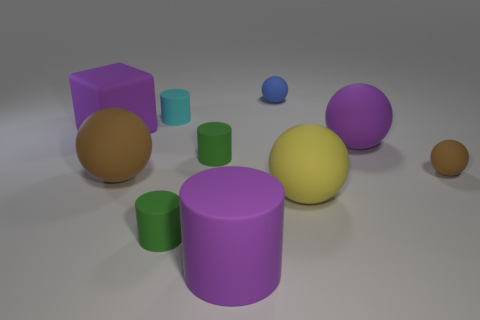Are there any purple things that are to the left of the small ball in front of the small cylinder behind the large matte block?
Your answer should be compact. Yes. There is a big purple object that is the same shape as the big yellow matte object; what is it made of?
Make the answer very short. Rubber. There is a rubber object that is behind the small cyan matte cylinder; what is its color?
Your answer should be very brief. Blue. How big is the yellow thing?
Make the answer very short. Large. Does the blue matte ball have the same size as the brown matte thing that is right of the cyan rubber object?
Make the answer very short. Yes. There is a big rubber cube behind the cylinder in front of the small cylinder in front of the big brown object; what color is it?
Offer a terse response. Purple. Are the green object that is in front of the big yellow thing and the small blue object made of the same material?
Ensure brevity in your answer.  Yes. How many other objects are there of the same material as the purple ball?
Offer a very short reply. 9. What material is the brown thing that is the same size as the blue matte sphere?
Provide a short and direct response. Rubber. There is a tiny matte object right of the large yellow rubber ball; does it have the same shape as the small green rubber object that is in front of the large yellow object?
Offer a very short reply. No. 